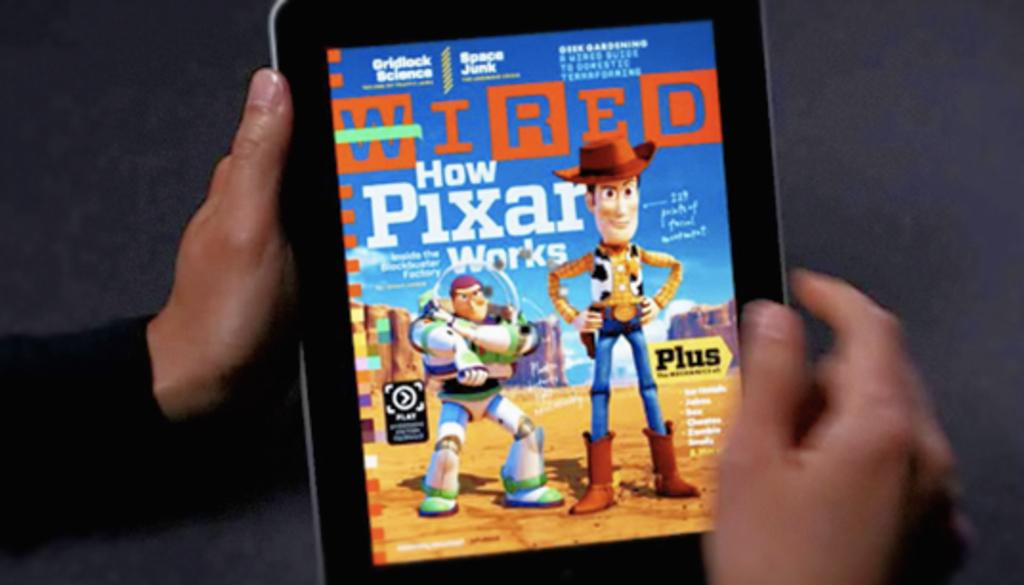<image>
Summarize the visual content of the image. The digital copy of Wired has an article about Pixar. 